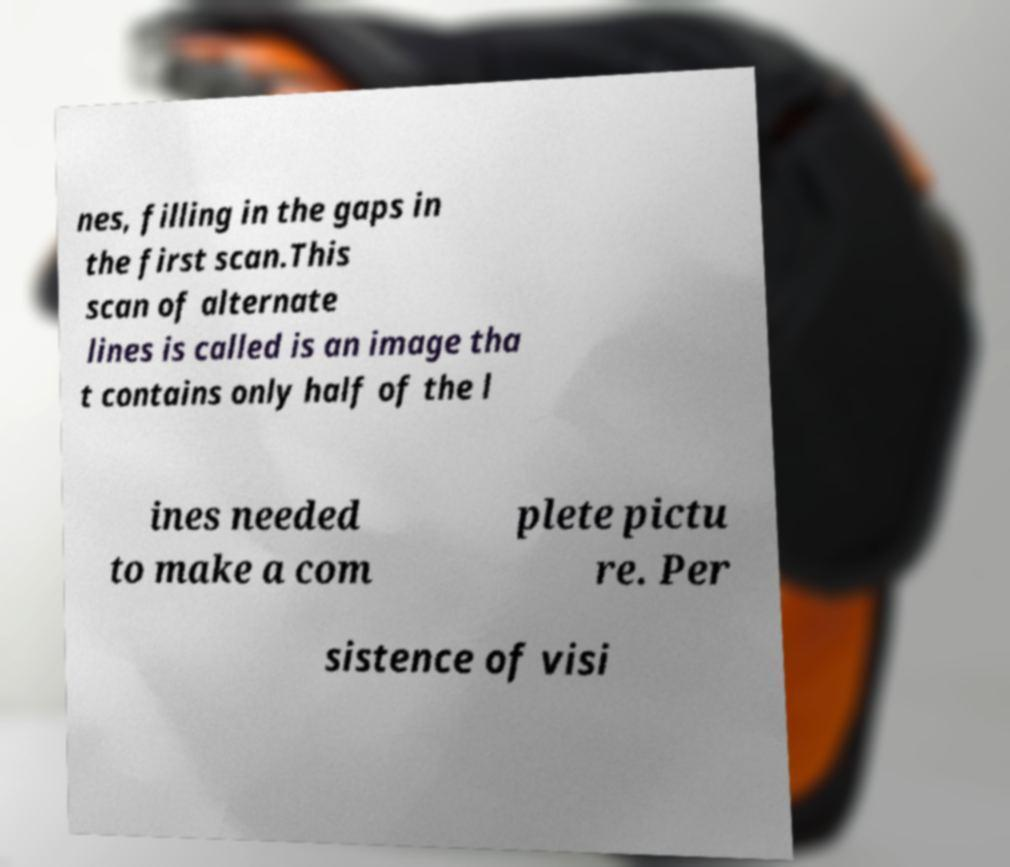There's text embedded in this image that I need extracted. Can you transcribe it verbatim? nes, filling in the gaps in the first scan.This scan of alternate lines is called is an image tha t contains only half of the l ines needed to make a com plete pictu re. Per sistence of visi 